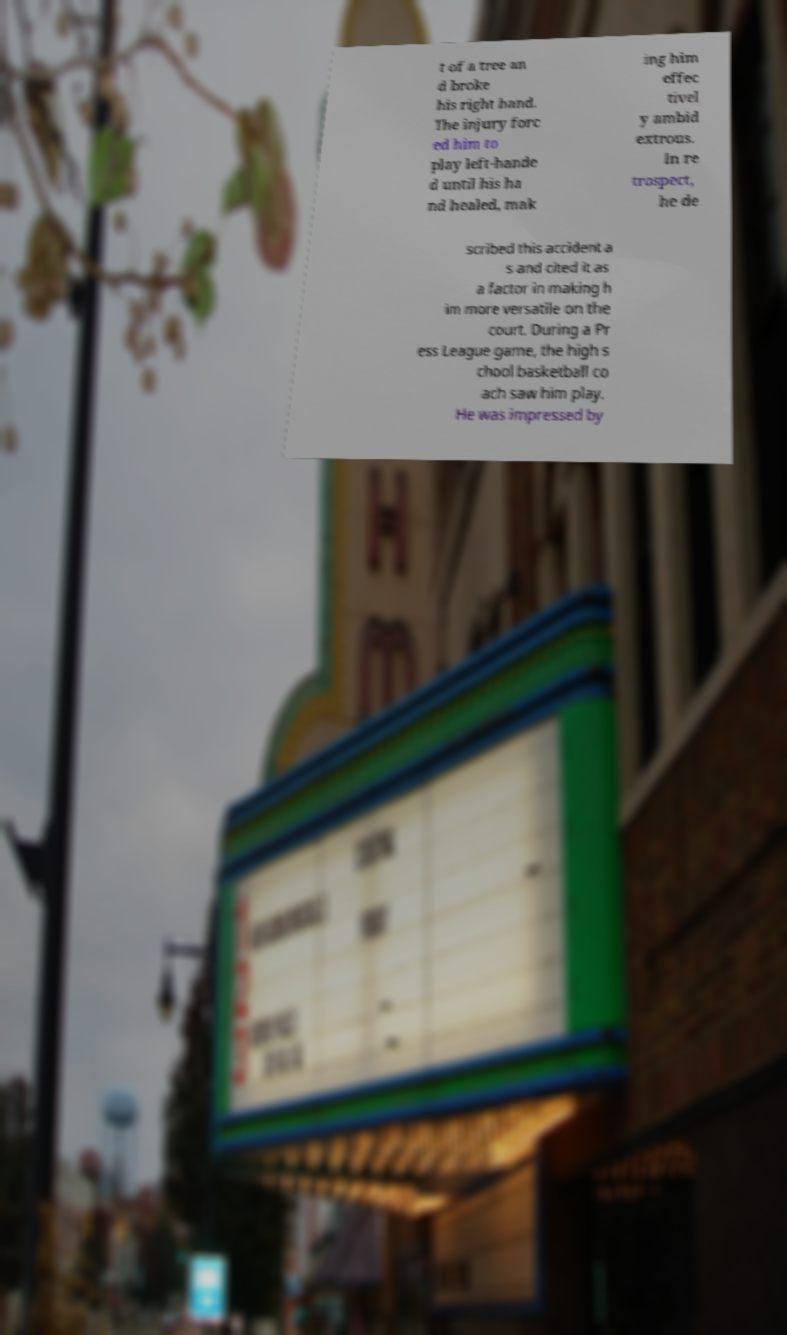What messages or text are displayed in this image? I need them in a readable, typed format. t of a tree an d broke his right hand. The injury forc ed him to play left-hande d until his ha nd healed, mak ing him effec tivel y ambid extrous. In re trospect, he de scribed this accident a s and cited it as a factor in making h im more versatile on the court. During a Pr ess League game, the high s chool basketball co ach saw him play. He was impressed by 